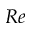Convert formula to latex. <formula><loc_0><loc_0><loc_500><loc_500>R e</formula> 